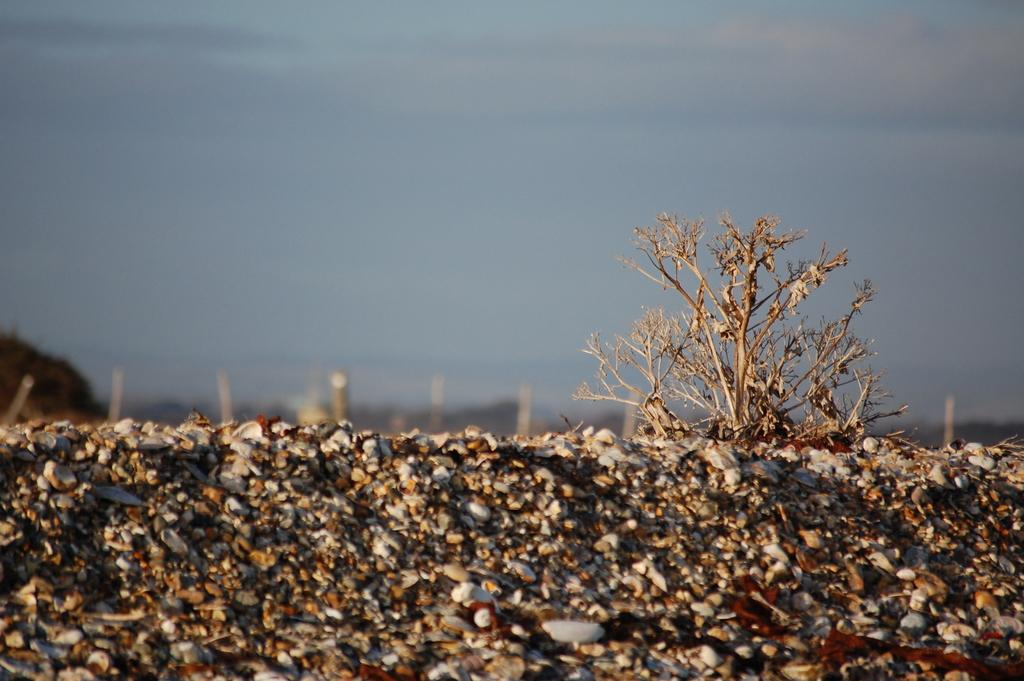What type of natural elements can be seen in the image? There are stones and a plant visible in the image. What can be seen in the background of the image? Places are visible in the background of the image. What is visible at the top of the image? The sky is visible at the top of the image. What type of sea creature can be seen crawling on the wrist in the image? There is no sea creature or wrist present in the image. Can you tell me the direction the sun is setting in the image? The image does not show the sun or any indication of a sunset, so it is not possible to determine the direction of the sun. 